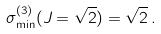Convert formula to latex. <formula><loc_0><loc_0><loc_500><loc_500>\sigma _ { \min } ^ { ( 3 ) } ( J = \sqrt { 2 } ) = \sqrt { 2 } \, .</formula> 